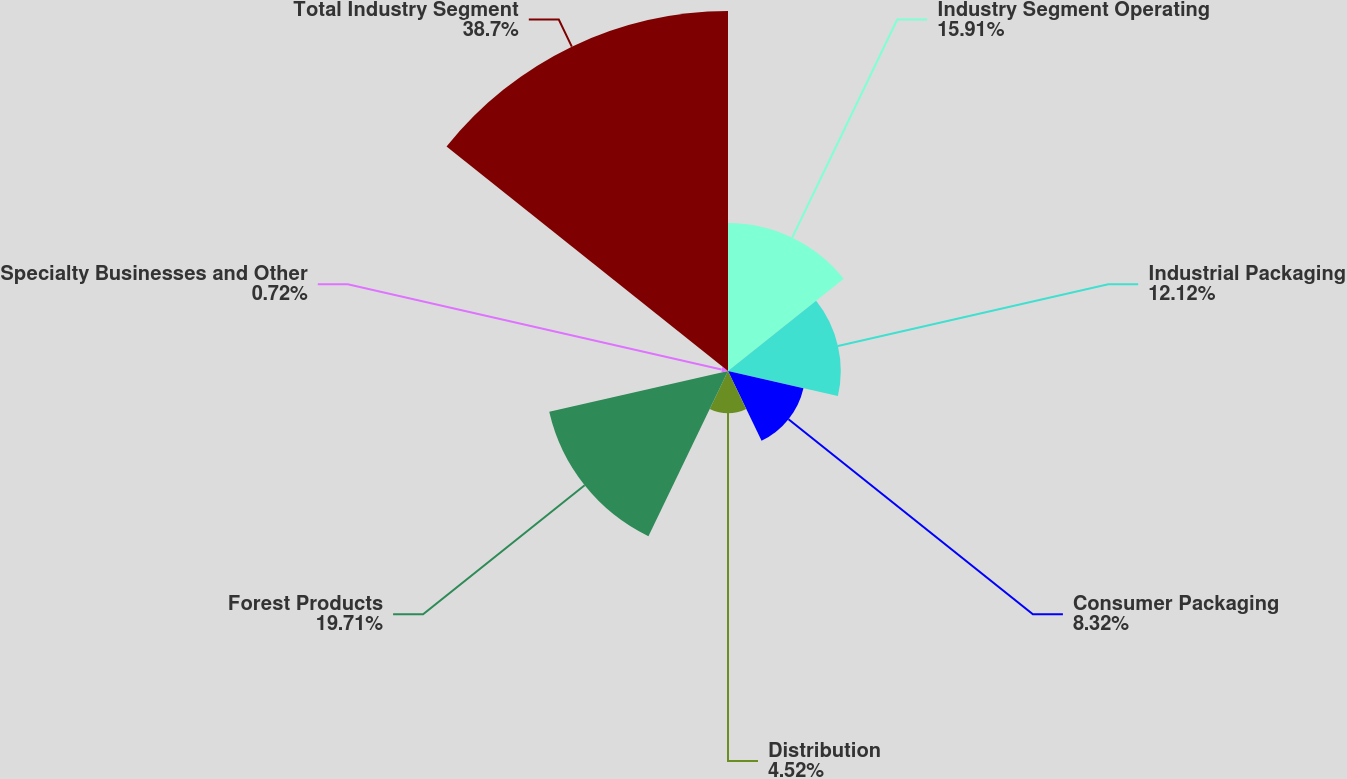<chart> <loc_0><loc_0><loc_500><loc_500><pie_chart><fcel>Industry Segment Operating<fcel>Industrial Packaging<fcel>Consumer Packaging<fcel>Distribution<fcel>Forest Products<fcel>Specialty Businesses and Other<fcel>Total Industry Segment<nl><fcel>15.91%<fcel>12.12%<fcel>8.32%<fcel>4.52%<fcel>19.71%<fcel>0.72%<fcel>38.7%<nl></chart> 